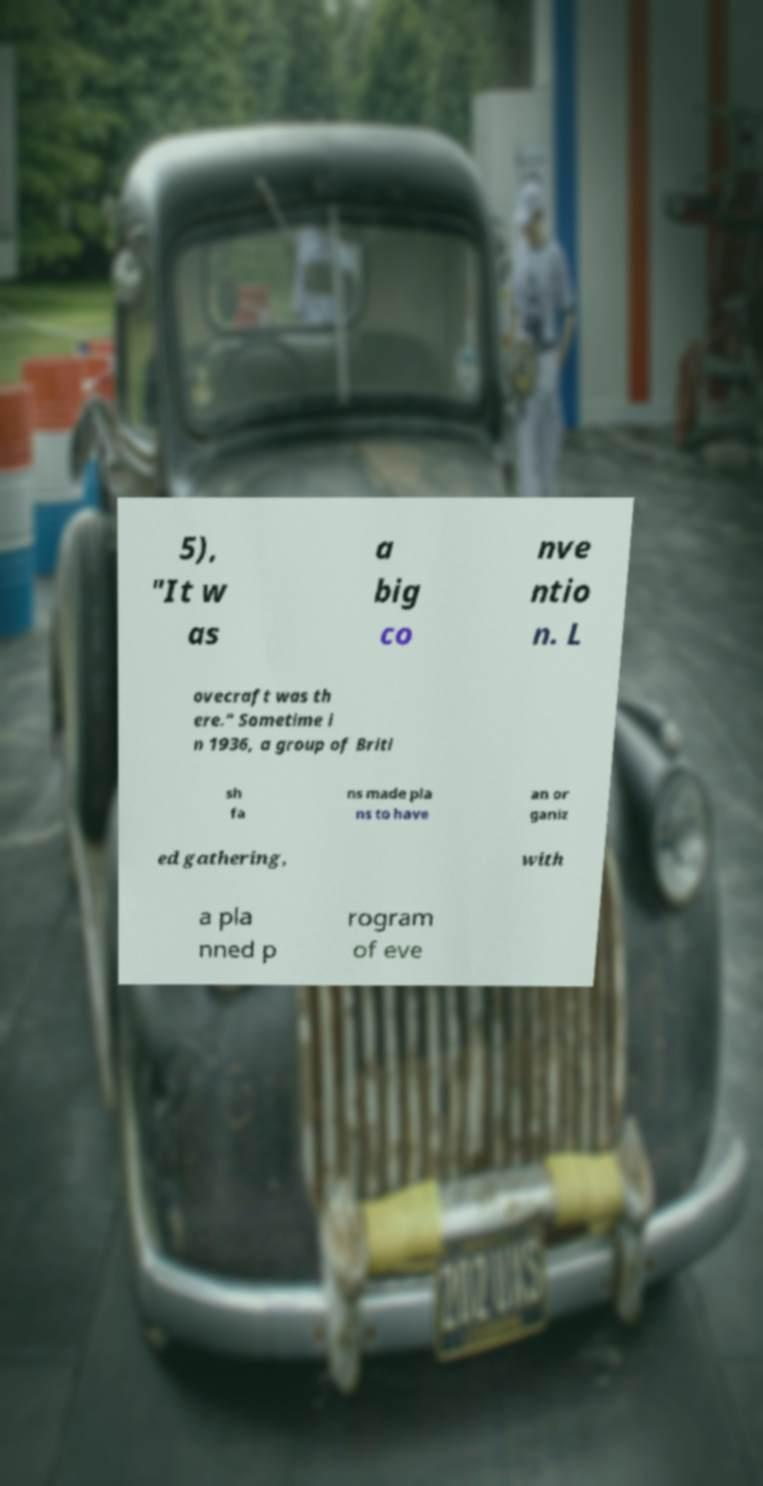Could you assist in decoding the text presented in this image and type it out clearly? 5), "It w as a big co nve ntio n. L ovecraft was th ere." Sometime i n 1936, a group of Briti sh fa ns made pla ns to have an or ganiz ed gathering, with a pla nned p rogram of eve 